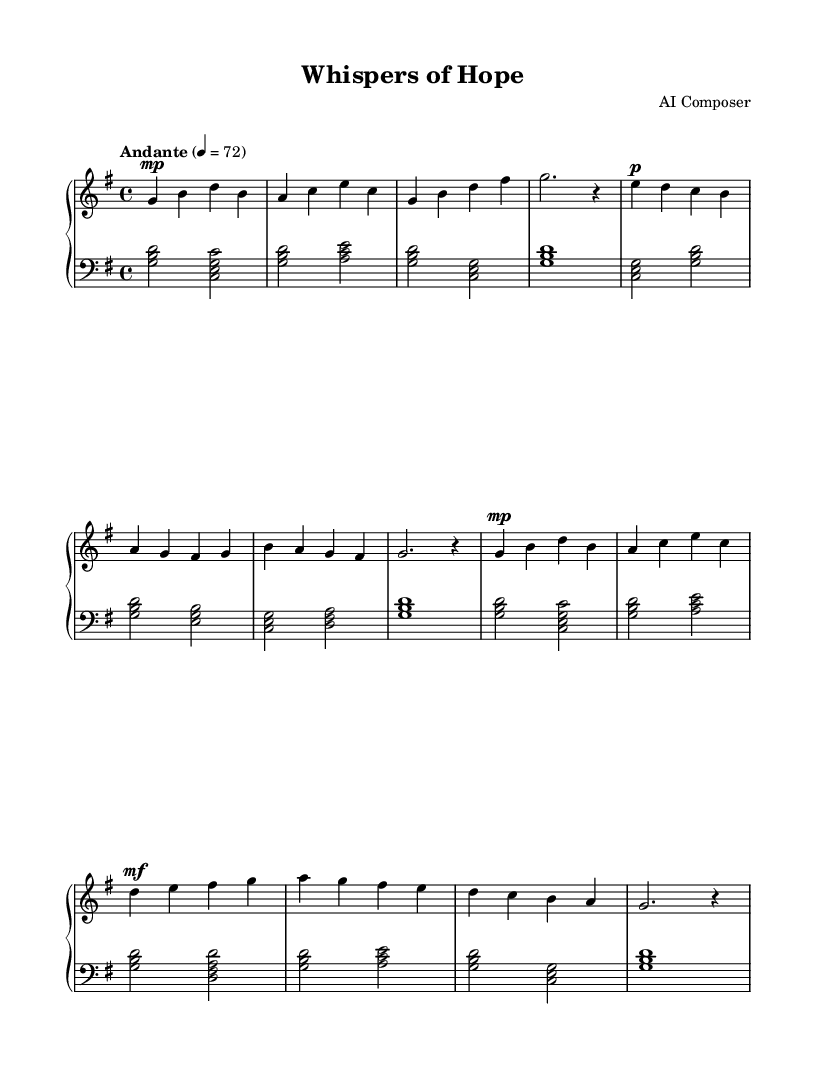what is the key signature of this music? The key signature indicated at the beginning of the music is G major, which has one sharp (F#). This is seen in the global settings at the start of the score.
Answer: G major what is the time signature of this music? The time signature shown at the beginning of the music is 4/4, which means there are four beats per measure, and the quarter note gets one beat. This is explicitly stated in the global settings.
Answer: 4/4 what is the tempo marking for this piece? The tempo marking in the score is "Andante," which indicates a moderate pace. Additionally, there's a specific metronome marking of 72 beats per minute, which provides a precise measure of the tempo.
Answer: Andante how many sections are there in the music? The piece consists of four sections: Section A, Section B, Section A' (abbreviated), and Section C. This is determined by the labeled structure and the repeated sections in the right hand part of the music.
Answer: 4 which dynamic marking is present in Section C? Section C starts with a mezzo-forte (mf) dynamic marking, indicating a medium loudness. This marking is found at the beginning of Section C, which is indicated within the right-hand part of the music.
Answer: mezzo-forte how is the left hand's first chord structured? The first chord of the left hand, which occurs in Section A, is a triad consisting of G, B, and D. This structure can be seen in the first measure of the left hand, indicating a G major chord.
Answer: G major what is the overall mood described by the title of the piece? The title "Whispers of Hope" suggests a calm and gentle mood, reflective of soothing and healing moments. This is inferred from the title, which often sets the emotional tone for the music.
Answer: Calm and gentle 